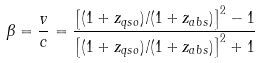<formula> <loc_0><loc_0><loc_500><loc_500>\beta = \frac { v } { c } = \frac { \left [ ( 1 + z _ { q s o } ) / ( 1 + z _ { a b s } ) \right ] ^ { 2 } - 1 } { \left [ ( 1 + z _ { q s o } ) / ( 1 + z _ { a b s } ) \right ] ^ { 2 } + 1 }</formula> 